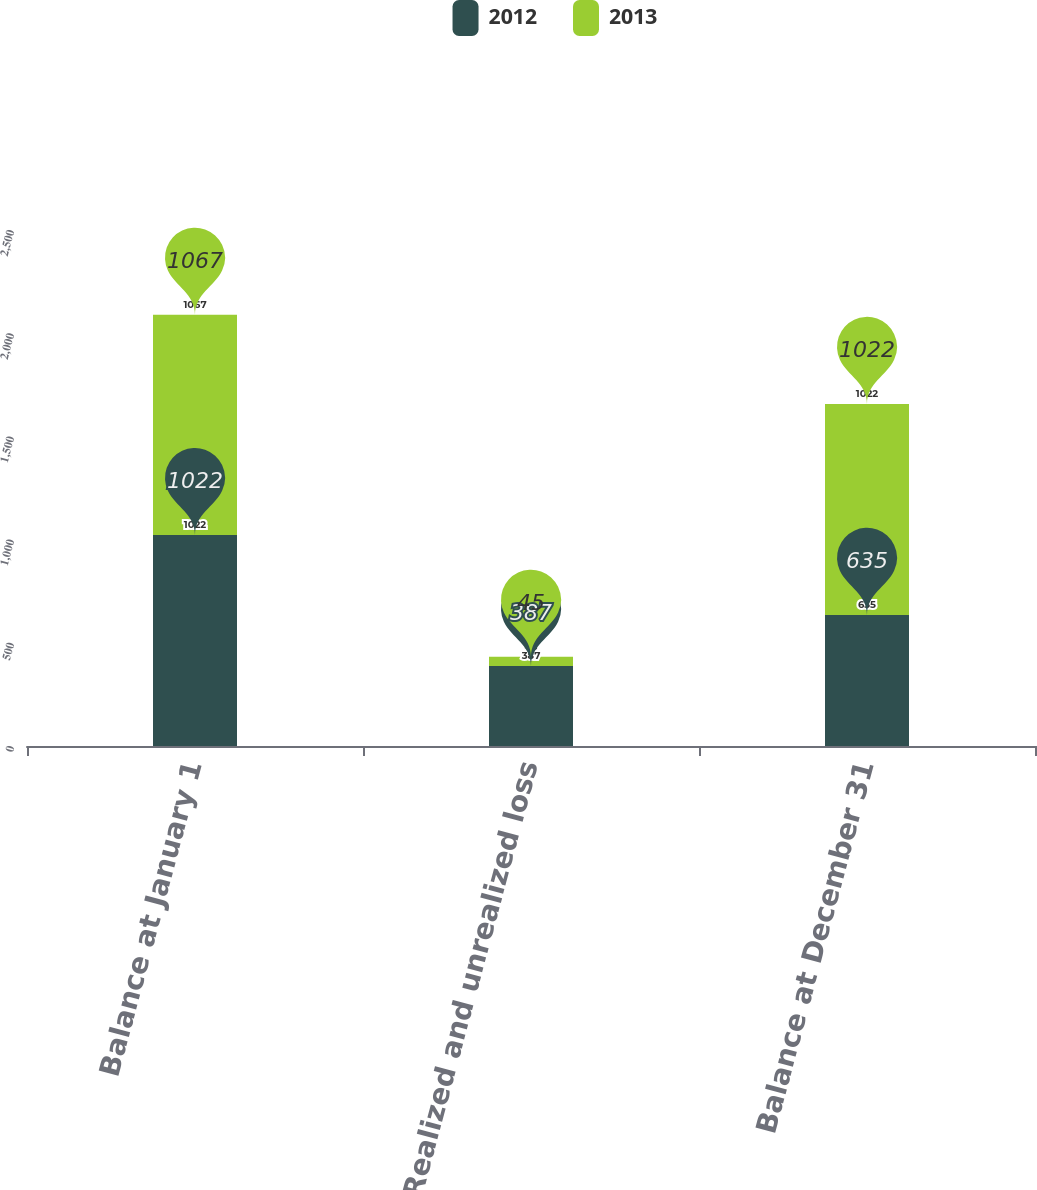Convert chart to OTSL. <chart><loc_0><loc_0><loc_500><loc_500><stacked_bar_chart><ecel><fcel>Balance at January 1<fcel>Realized and unrealized loss<fcel>Balance at December 31<nl><fcel>2012<fcel>1022<fcel>387<fcel>635<nl><fcel>2013<fcel>1067<fcel>45<fcel>1022<nl></chart> 